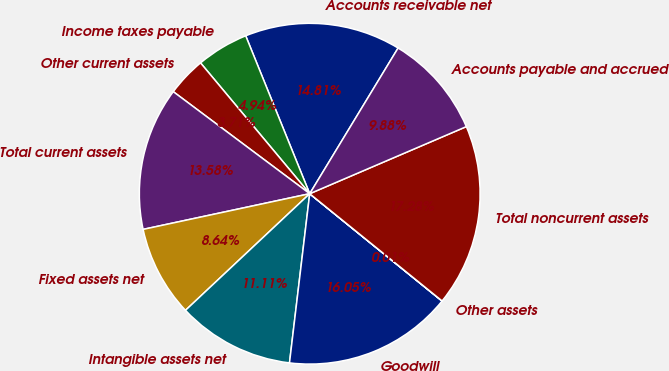Convert chart. <chart><loc_0><loc_0><loc_500><loc_500><pie_chart><fcel>Accounts receivable net<fcel>Income taxes payable<fcel>Other current assets<fcel>Total current assets<fcel>Fixed assets net<fcel>Intangible assets net<fcel>Goodwill<fcel>Other assets<fcel>Total noncurrent assets<fcel>Accounts payable and accrued<nl><fcel>14.81%<fcel>4.94%<fcel>3.71%<fcel>13.58%<fcel>8.64%<fcel>11.11%<fcel>16.05%<fcel>0.01%<fcel>17.28%<fcel>9.88%<nl></chart> 